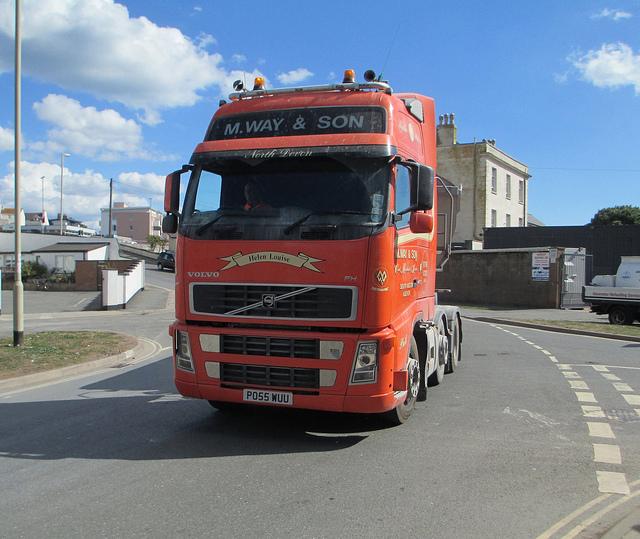How many wheels on the truck?
Keep it brief. 6. Does the street look busy?
Keep it brief. No. How many trucks are in the picture?
Keep it brief. 1. What do the white letters above the windshield say?
Be succinct. Mway & son. What color is the truck?
Answer briefly. Orange. What is the make of the truck?
Keep it brief. Volvo. How many wheels are visible in this picture?
Short answer required. 4. On which side of the cabin is the driver sitting?
Keep it brief. Right. 